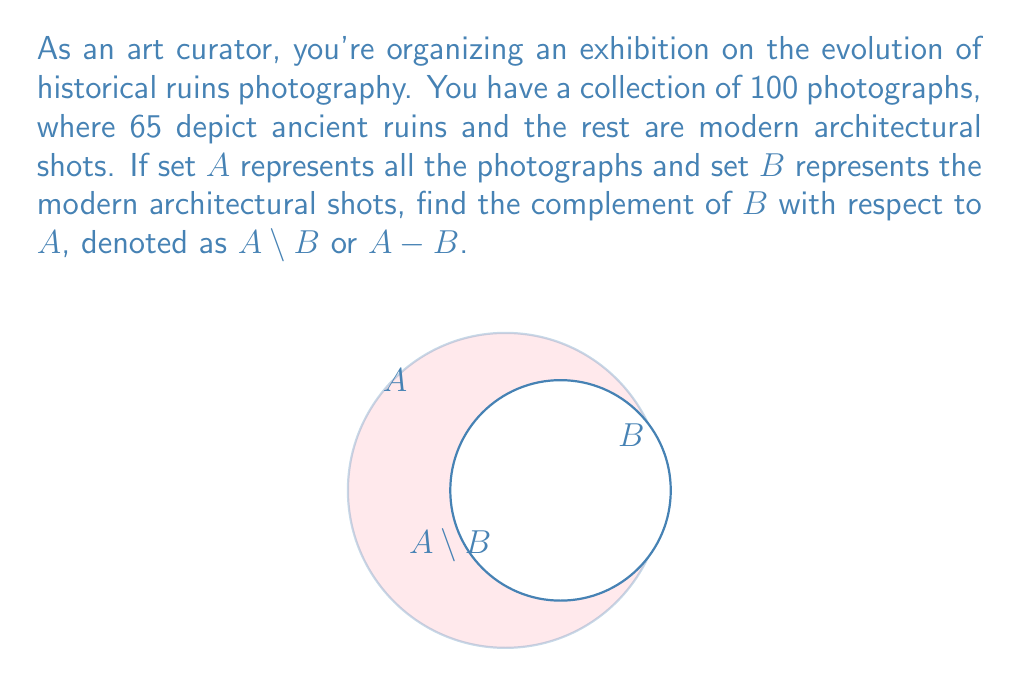Can you solve this math problem? To find the complement of set $B$ with respect to set $A$, we need to determine the elements that are in $A$ but not in $B$. Let's approach this step-by-step:

1. Define the universal set $A$:
   $|A| = 100$ (total number of photographs)

2. Identify set $B$:
   $B$ represents modern architectural shots
   $|B| = 100 - 65 = 35$ (as 65 are ancient ruins photographs)

3. The complement $A \setminus B$ consists of elements in $A$ that are not in $B$:
   $|A \setminus B| = |A| - |B|$

4. Calculate the cardinality of $A \setminus B$:
   $|A \setminus B| = 100 - 35 = 65$

5. Interpret the result:
   The complement $A \setminus B$ represents the set of ancient ruins photographs, which is what we're looking for in this context.

Therefore, $A \setminus B$ contains 65 photographs, all depicting ancient ruins.
Answer: $|A \setminus B| = 65$ 